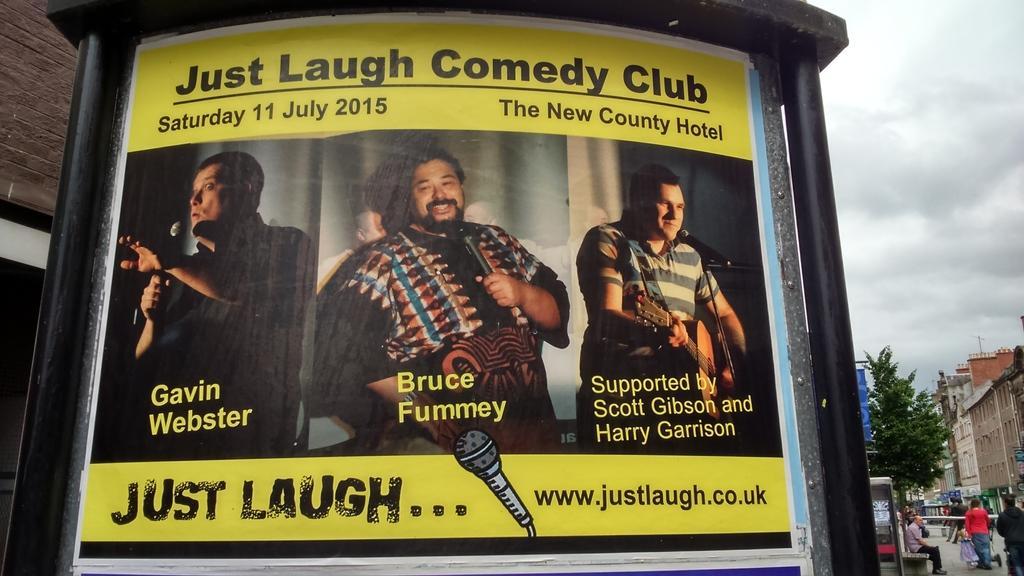Could you give a brief overview of what you see in this image? In this image, there is a black color wall on that there is a poster which is in yellow color on that poster there is just laugh written on that. 